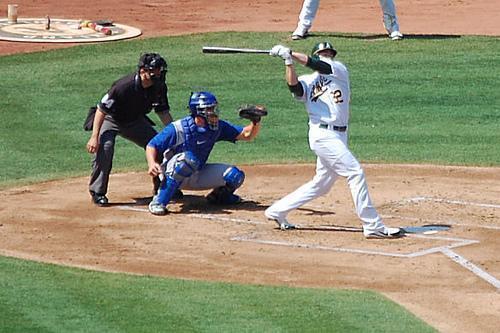What call will the umpire most likely make?
Choose the right answer from the provided options to respond to the question.
Options: Foul, out, strike, ball. Strike. 